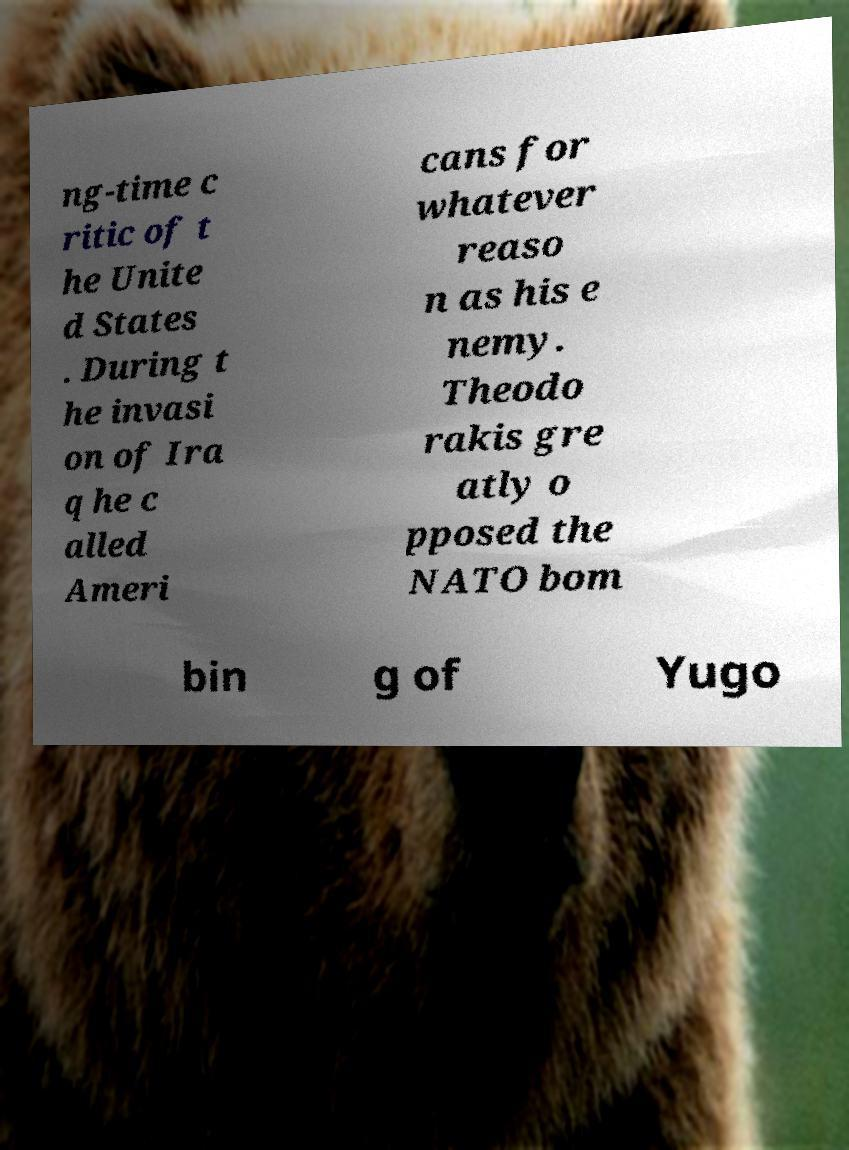Can you read and provide the text displayed in the image?This photo seems to have some interesting text. Can you extract and type it out for me? ng-time c ritic of t he Unite d States . During t he invasi on of Ira q he c alled Ameri cans for whatever reaso n as his e nemy. Theodo rakis gre atly o pposed the NATO bom bin g of Yugo 